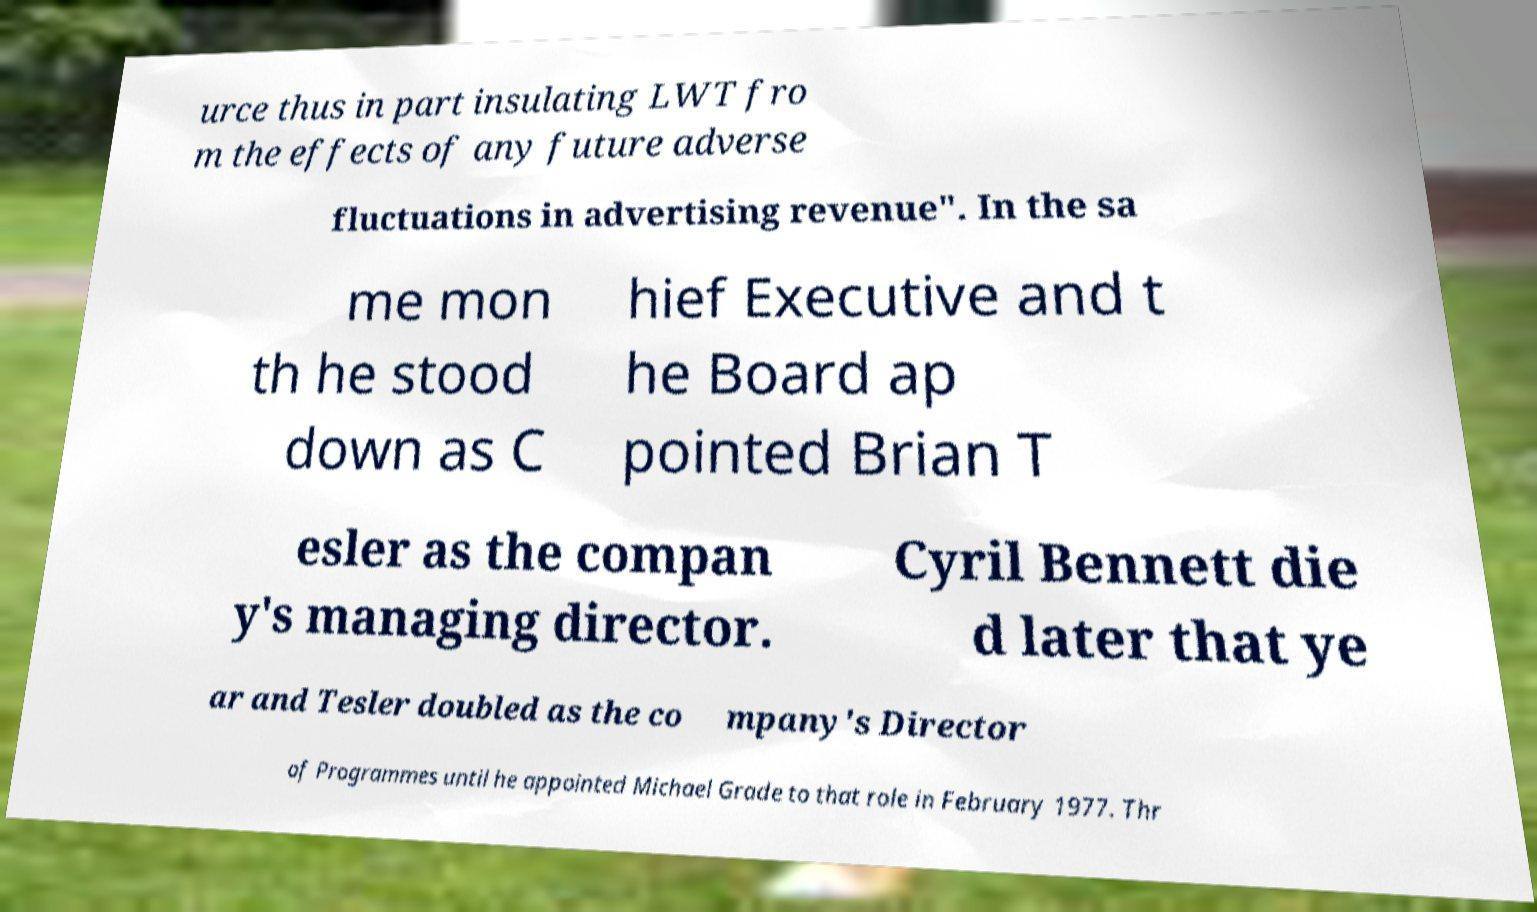Please read and relay the text visible in this image. What does it say? urce thus in part insulating LWT fro m the effects of any future adverse fluctuations in advertising revenue". In the sa me mon th he stood down as C hief Executive and t he Board ap pointed Brian T esler as the compan y's managing director. Cyril Bennett die d later that ye ar and Tesler doubled as the co mpany's Director of Programmes until he appointed Michael Grade to that role in February 1977. Thr 